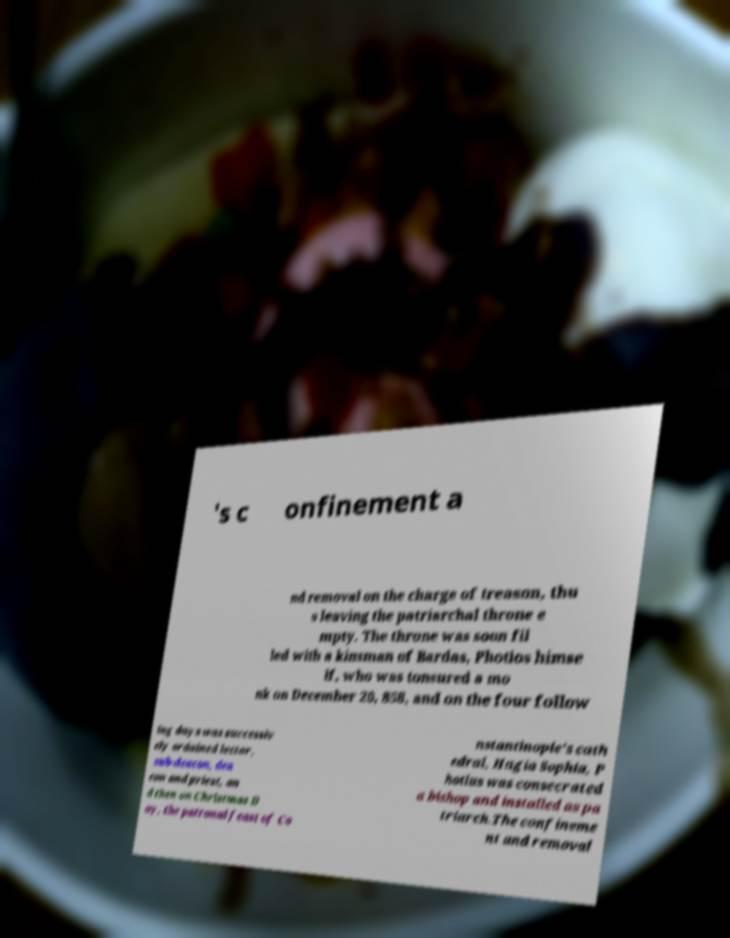For documentation purposes, I need the text within this image transcribed. Could you provide that? 's c onfinement a nd removal on the charge of treason, thu s leaving the patriarchal throne e mpty. The throne was soon fil led with a kinsman of Bardas, Photios himse lf, who was tonsured a mo nk on December 20, 858, and on the four follow ing days was successiv ely ordained lector, sub-deacon, dea con and priest, an d then on Christmas D ay, the patronal feast of Co nstantinople's cath edral, Hagia Sophia, P hotius was consecrated a bishop and installed as pa triarch.The confineme nt and removal 